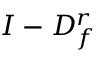<formula> <loc_0><loc_0><loc_500><loc_500>I - D _ { f } ^ { r }</formula> 